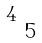<formula> <loc_0><loc_0><loc_500><loc_500>\begin{smallmatrix} 4 & & \ \\ & 5 & \end{smallmatrix}</formula> 